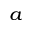<formula> <loc_0><loc_0><loc_500><loc_500>^ { a }</formula> 